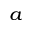<formula> <loc_0><loc_0><loc_500><loc_500>^ { a }</formula> 